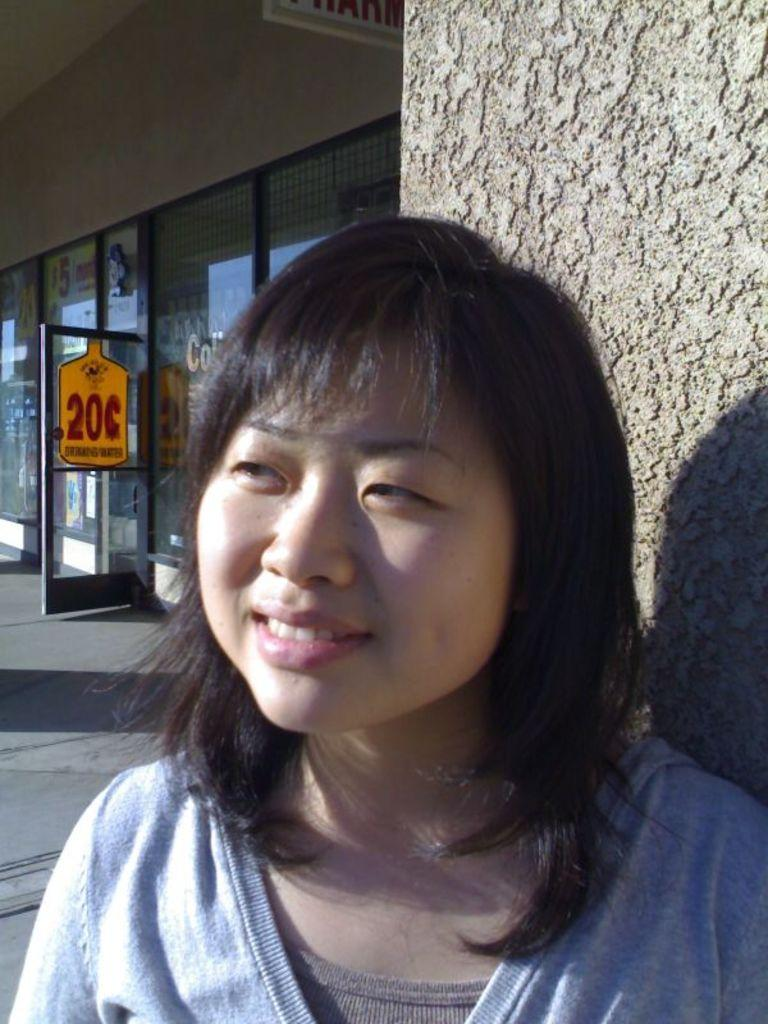Who is in the image? There is a woman in the image. What is the woman doing? The woman is smiling. What is behind the woman? There is a wall behind the woman. What can be seen on the glass in the background of the image? There are posters on the glass in the background of the image. What else is visible in the background of the image? There is a board in the background of the image. How many chairs are stacked on the crate in the image? There is no crate or chairs present in the image. 